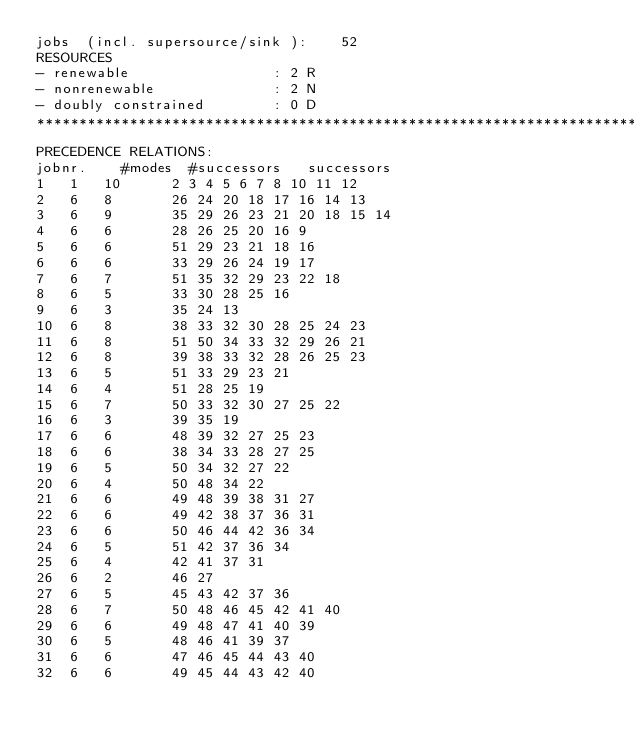<code> <loc_0><loc_0><loc_500><loc_500><_ObjectiveC_>jobs  (incl. supersource/sink ):	52
RESOURCES
- renewable                 : 2 R
- nonrenewable              : 2 N
- doubly constrained        : 0 D
************************************************************************
PRECEDENCE RELATIONS:
jobnr.    #modes  #successors   successors
1	1	10		2 3 4 5 6 7 8 10 11 12 
2	6	8		26 24 20 18 17 16 14 13 
3	6	9		35 29 26 23 21 20 18 15 14 
4	6	6		28 26 25 20 16 9 
5	6	6		51 29 23 21 18 16 
6	6	6		33 29 26 24 19 17 
7	6	7		51 35 32 29 23 22 18 
8	6	5		33 30 28 25 16 
9	6	3		35 24 13 
10	6	8		38 33 32 30 28 25 24 23 
11	6	8		51 50 34 33 32 29 26 21 
12	6	8		39 38 33 32 28 26 25 23 
13	6	5		51 33 29 23 21 
14	6	4		51 28 25 19 
15	6	7		50 33 32 30 27 25 22 
16	6	3		39 35 19 
17	6	6		48 39 32 27 25 23 
18	6	6		38 34 33 28 27 25 
19	6	5		50 34 32 27 22 
20	6	4		50 48 34 22 
21	6	6		49 48 39 38 31 27 
22	6	6		49 42 38 37 36 31 
23	6	6		50 46 44 42 36 34 
24	6	5		51 42 37 36 34 
25	6	4		42 41 37 31 
26	6	2		46 27 
27	6	5		45 43 42 37 36 
28	6	7		50 48 46 45 42 41 40 
29	6	6		49 48 47 41 40 39 
30	6	5		48 46 41 39 37 
31	6	6		47 46 45 44 43 40 
32	6	6		49 45 44 43 42 40 </code> 